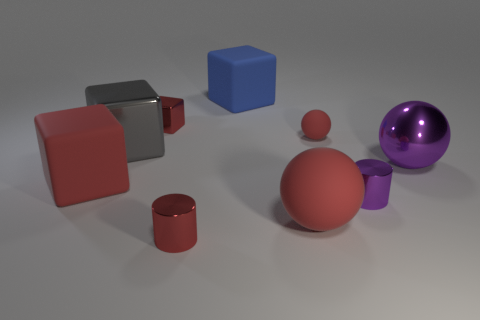What is the material of the purple sphere that is the same size as the blue matte thing?
Your answer should be very brief. Metal. Is the color of the small cube the same as the small sphere?
Provide a succinct answer. Yes. How big is the purple shiny cylinder?
Your answer should be very brief. Small. What material is the small cylinder that is the same color as the large matte sphere?
Provide a short and direct response. Metal. How many big rubber spheres have the same color as the tiny matte ball?
Provide a succinct answer. 1. Does the blue cube have the same size as the purple metallic cylinder?
Make the answer very short. No. How big is the shiny block behind the tiny red rubber thing behind the small red shiny cylinder?
Keep it short and to the point. Small. There is a big matte sphere; is it the same color as the small cylinder that is on the left side of the large rubber ball?
Make the answer very short. Yes. Is there a purple object that has the same size as the gray metallic block?
Keep it short and to the point. Yes. How big is the purple metal object in front of the big metal ball?
Offer a very short reply. Small. 